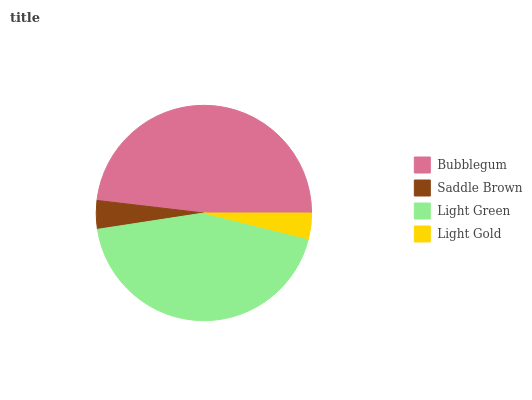Is Light Gold the minimum?
Answer yes or no. Yes. Is Bubblegum the maximum?
Answer yes or no. Yes. Is Saddle Brown the minimum?
Answer yes or no. No. Is Saddle Brown the maximum?
Answer yes or no. No. Is Bubblegum greater than Saddle Brown?
Answer yes or no. Yes. Is Saddle Brown less than Bubblegum?
Answer yes or no. Yes. Is Saddle Brown greater than Bubblegum?
Answer yes or no. No. Is Bubblegum less than Saddle Brown?
Answer yes or no. No. Is Light Green the high median?
Answer yes or no. Yes. Is Saddle Brown the low median?
Answer yes or no. Yes. Is Saddle Brown the high median?
Answer yes or no. No. Is Bubblegum the low median?
Answer yes or no. No. 